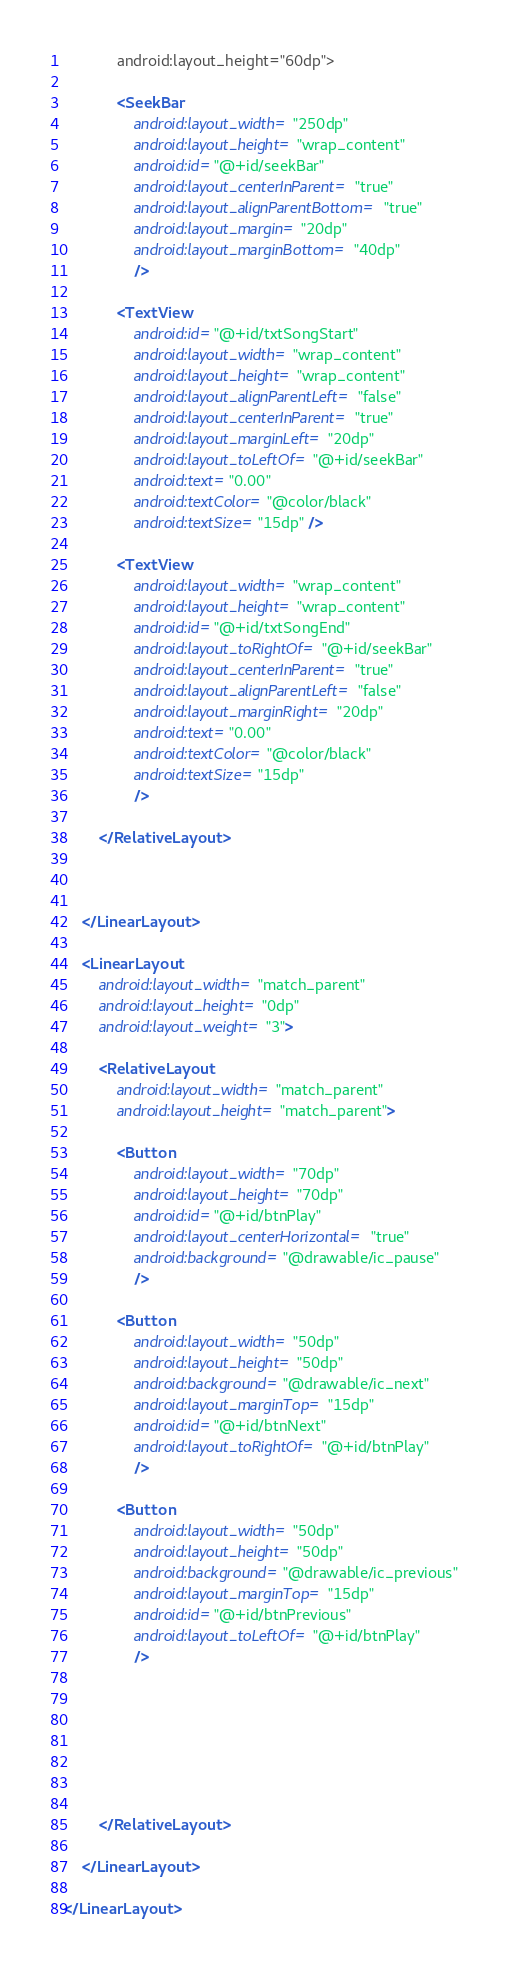Convert code to text. <code><loc_0><loc_0><loc_500><loc_500><_XML_>            android:layout_height="60dp">

            <SeekBar
                android:layout_width="250dp"
                android:layout_height="wrap_content"
                android:id="@+id/seekBar"
                android:layout_centerInParent="true"
                android:layout_alignParentBottom="true"
                android:layout_margin="20dp"
                android:layout_marginBottom="40dp"
                />

            <TextView
                android:id="@+id/txtSongStart"
                android:layout_width="wrap_content"
                android:layout_height="wrap_content"
                android:layout_alignParentLeft="false"
                android:layout_centerInParent="true"
                android:layout_marginLeft="20dp"
                android:layout_toLeftOf="@+id/seekBar"
                android:text="0.00"
                android:textColor="@color/black"
                android:textSize="15dp" />

            <TextView
                android:layout_width="wrap_content"
                android:layout_height="wrap_content"
                android:id="@+id/txtSongEnd"
                android:layout_toRightOf="@+id/seekBar"
                android:layout_centerInParent="true"
                android:layout_alignParentLeft="false"
                android:layout_marginRight="20dp"
                android:text="0.00"
                android:textColor="@color/black"
                android:textSize="15dp"
                />

        </RelativeLayout>



    </LinearLayout>

    <LinearLayout
        android:layout_width="match_parent"
        android:layout_height="0dp"
        android:layout_weight="3">

        <RelativeLayout
            android:layout_width="match_parent"
            android:layout_height="match_parent">

            <Button
                android:layout_width="70dp"
                android:layout_height="70dp"
                android:id="@+id/btnPlay"
                android:layout_centerHorizontal="true"
                android:background="@drawable/ic_pause"
                />

            <Button
                android:layout_width="50dp"
                android:layout_height="50dp"
                android:background="@drawable/ic_next"
                android:layout_marginTop="15dp"
                android:id="@+id/btnNext"
                android:layout_toRightOf="@+id/btnPlay"
                />

            <Button
                android:layout_width="50dp"
                android:layout_height="50dp"
                android:background="@drawable/ic_previous"
                android:layout_marginTop="15dp"
                android:id="@+id/btnPrevious"
                android:layout_toLeftOf="@+id/btnPlay"
                />







        </RelativeLayout>

    </LinearLayout>

</LinearLayout></code> 